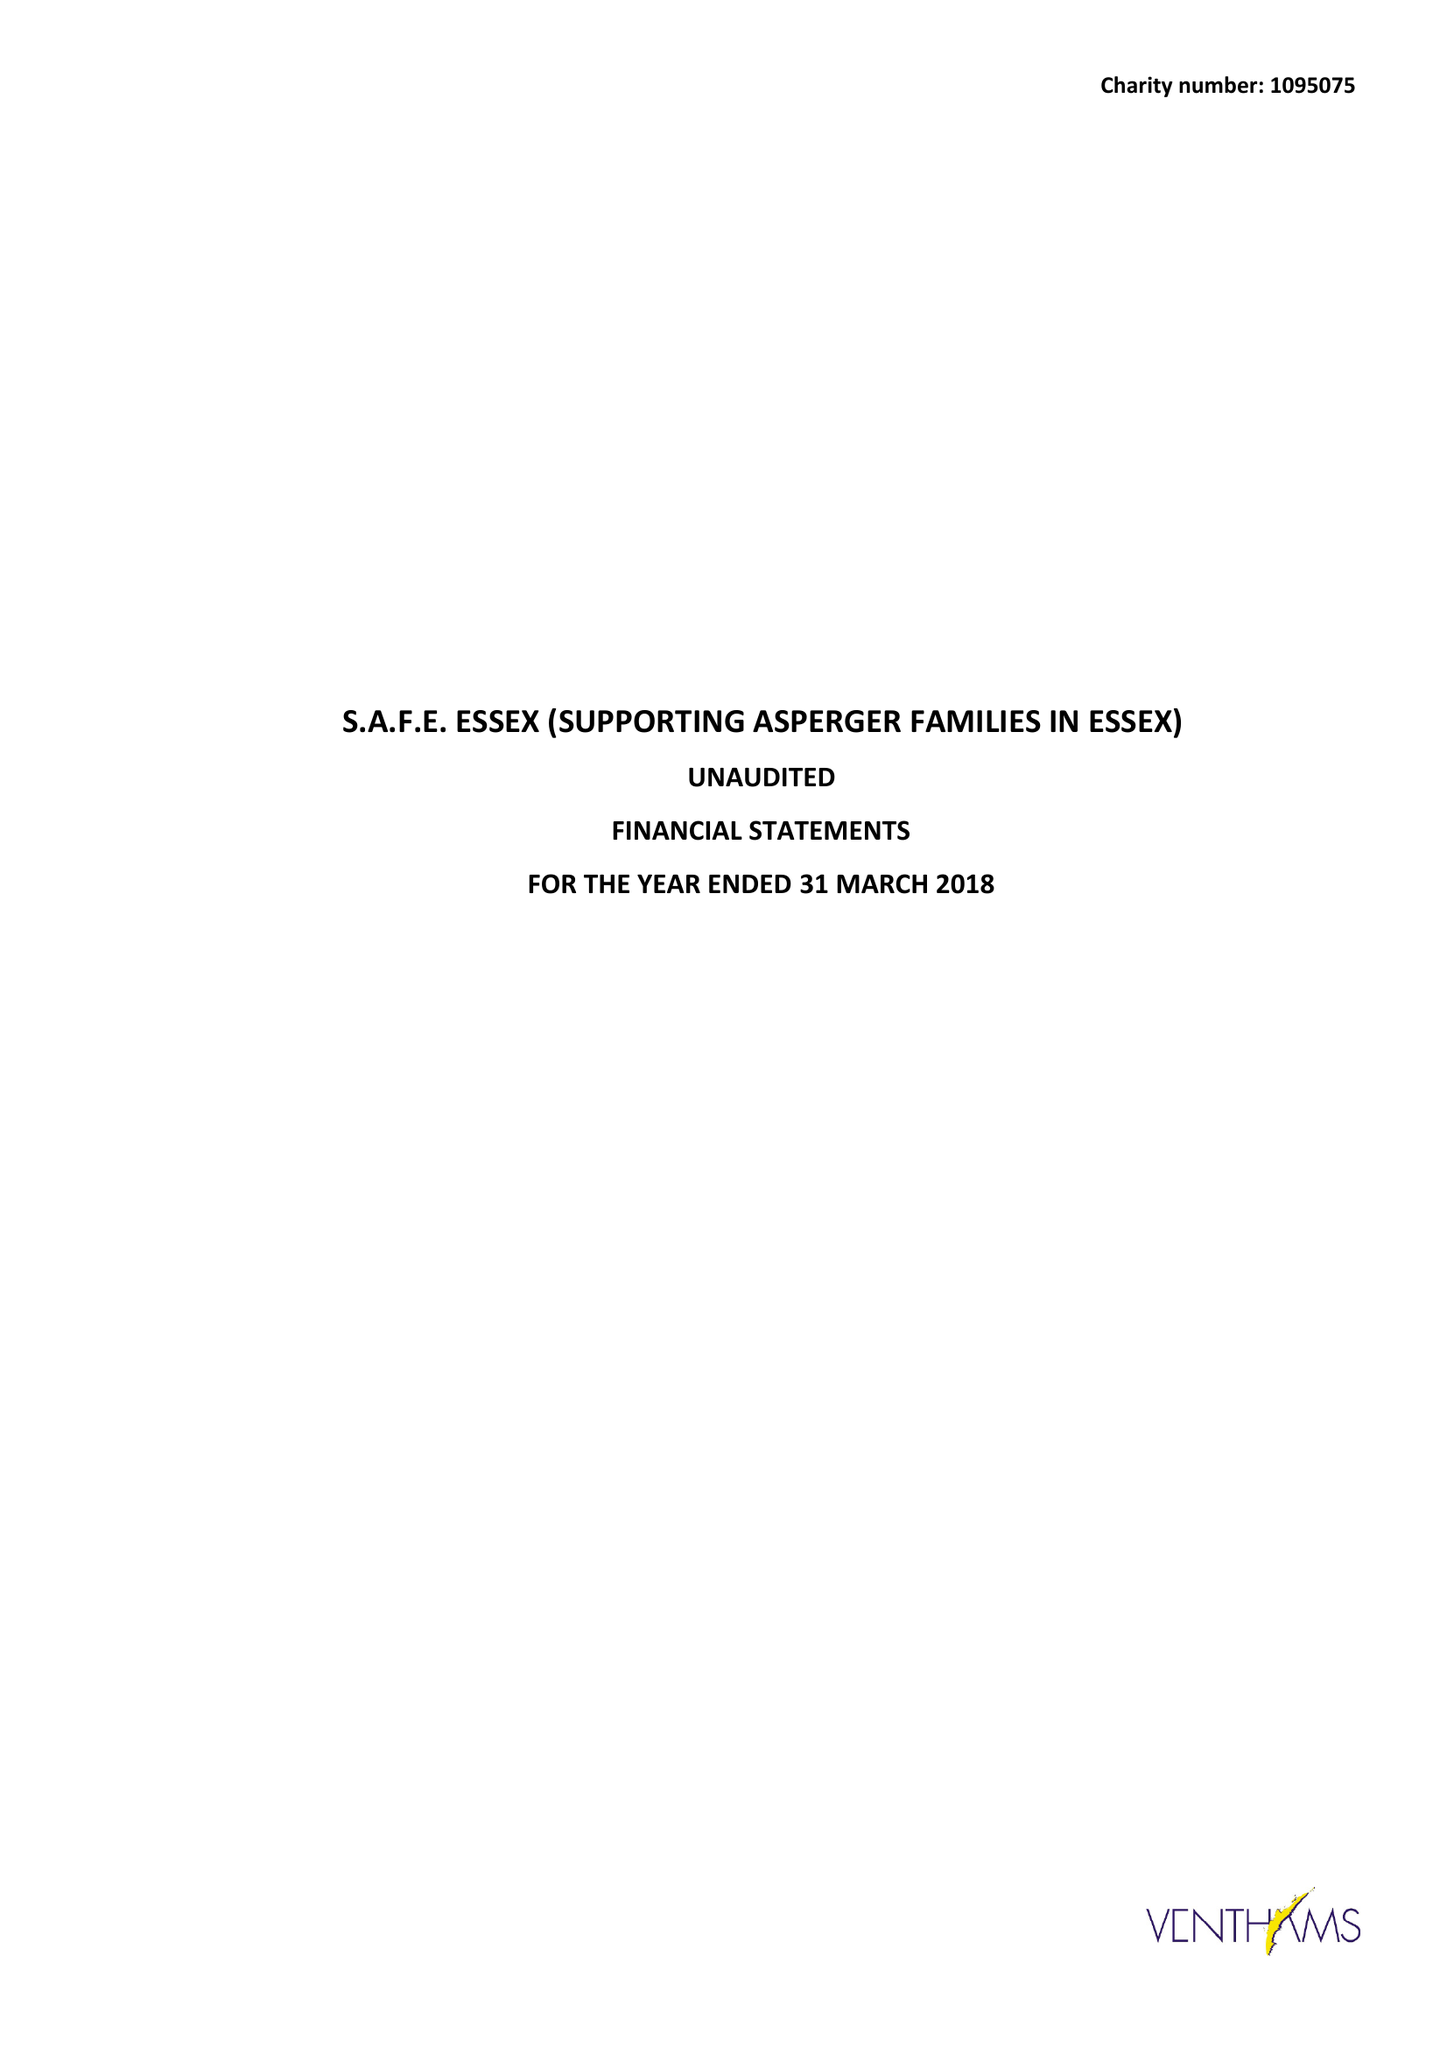What is the value for the charity_number?
Answer the question using a single word or phrase. 1095075 